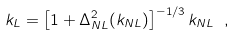<formula> <loc_0><loc_0><loc_500><loc_500>k _ { L } = \left [ 1 + \Delta _ { N L } ^ { 2 } ( k _ { N L } ) \right ] ^ { - 1 / 3 } k _ { N L } \ ,</formula> 